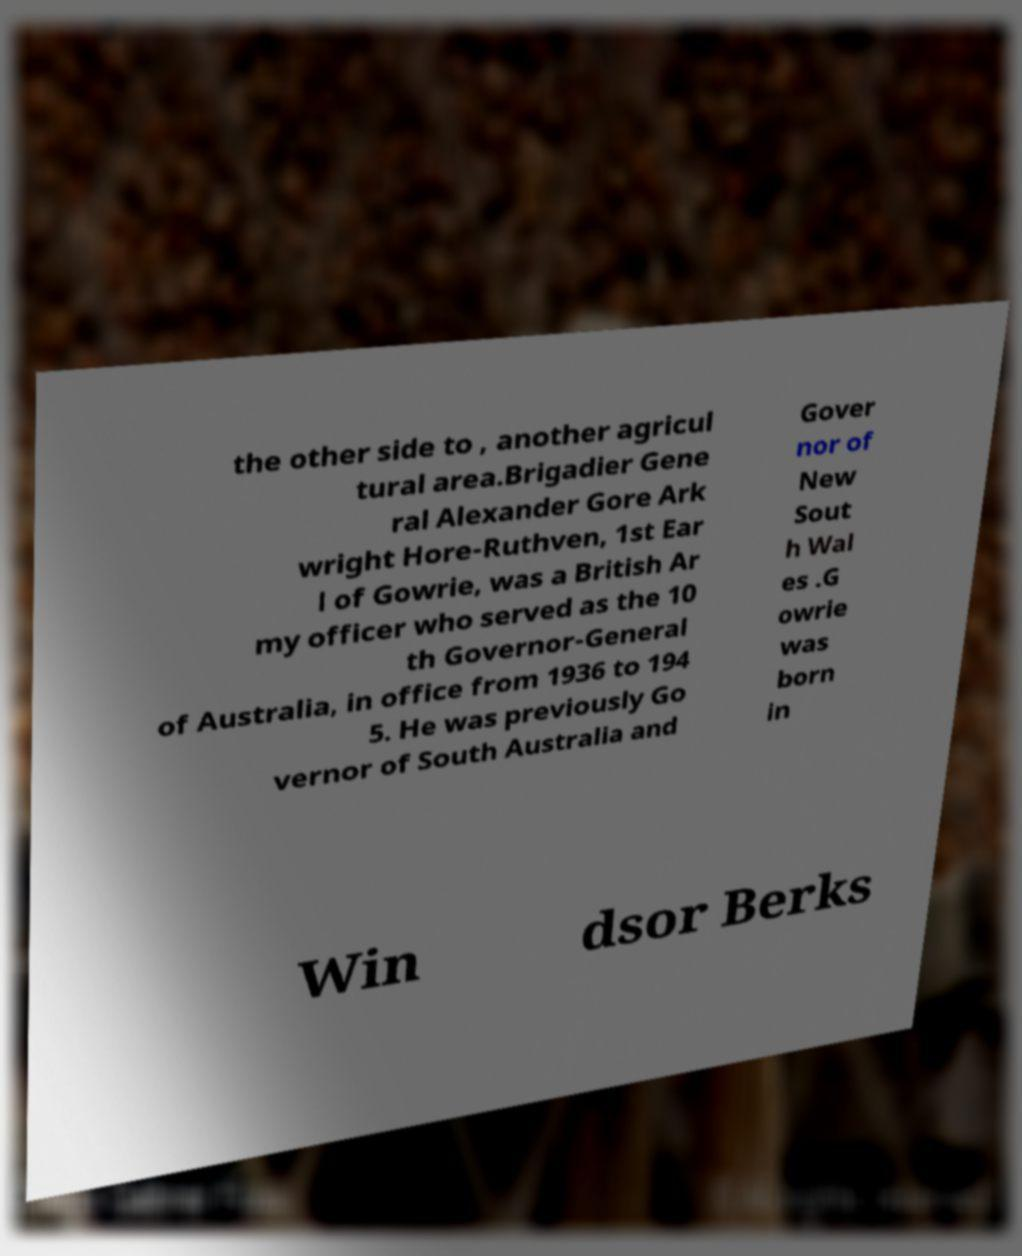I need the written content from this picture converted into text. Can you do that? the other side to , another agricul tural area.Brigadier Gene ral Alexander Gore Ark wright Hore-Ruthven, 1st Ear l of Gowrie, was a British Ar my officer who served as the 10 th Governor-General of Australia, in office from 1936 to 194 5. He was previously Go vernor of South Australia and Gover nor of New Sout h Wal es .G owrie was born in Win dsor Berks 